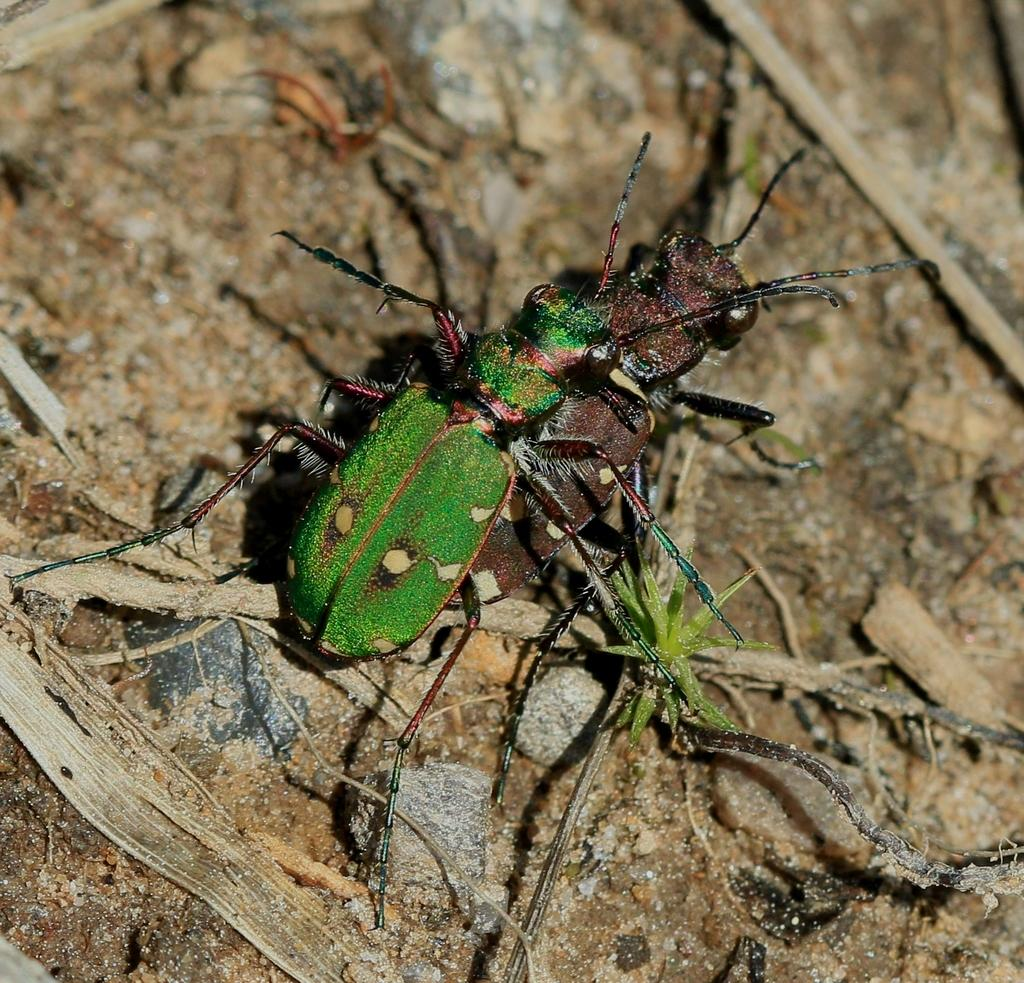What type of insect is in the image? There is a tiger beetle in the image. What type of terrain is visible in the image? There is sand in the image. What type of print is visible on the tiger beetle's back in the image? There is no print visible on the tiger beetle's back in the image. 